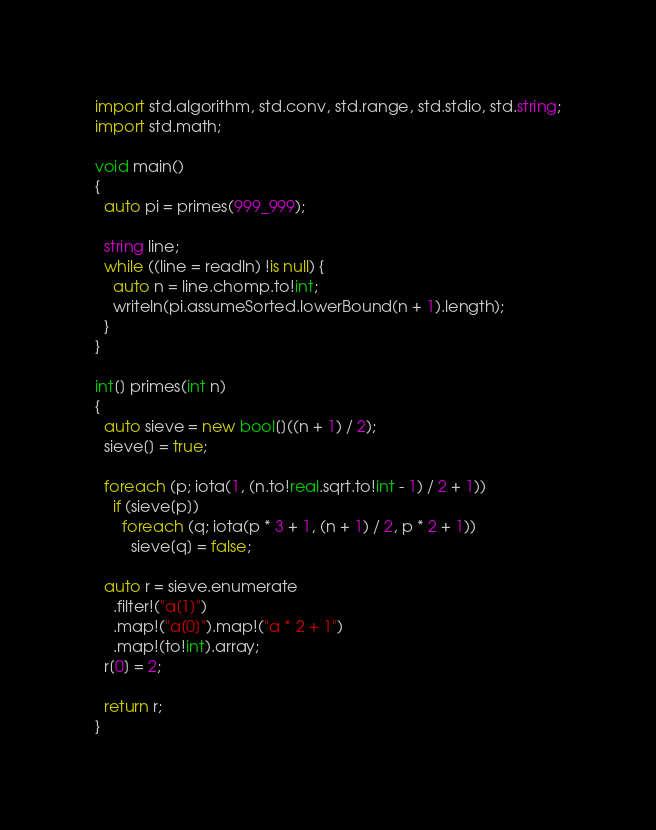Convert code to text. <code><loc_0><loc_0><loc_500><loc_500><_D_>import std.algorithm, std.conv, std.range, std.stdio, std.string;
import std.math;

void main()
{
  auto pi = primes(999_999);

  string line;
  while ((line = readln) !is null) {
    auto n = line.chomp.to!int;
    writeln(pi.assumeSorted.lowerBound(n + 1).length);
  }
}

int[] primes(int n)
{
  auto sieve = new bool[]((n + 1) / 2);
  sieve[] = true;

  foreach (p; iota(1, (n.to!real.sqrt.to!int - 1) / 2 + 1))
    if (sieve[p])
      foreach (q; iota(p * 3 + 1, (n + 1) / 2, p * 2 + 1))
        sieve[q] = false;

  auto r = sieve.enumerate
    .filter!("a[1]")
    .map!("a[0]").map!("a * 2 + 1")
    .map!(to!int).array;
  r[0] = 2;

  return r;
}</code> 